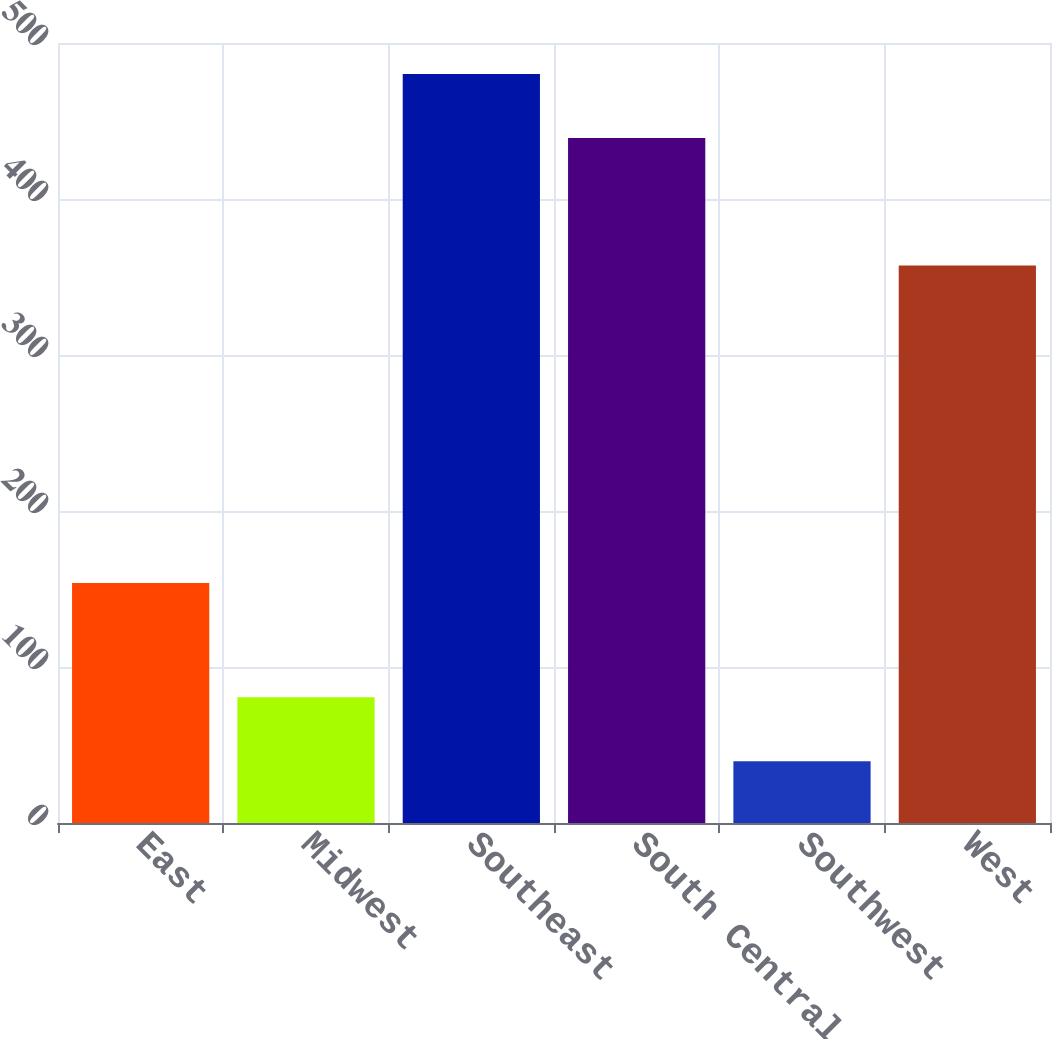Convert chart. <chart><loc_0><loc_0><loc_500><loc_500><bar_chart><fcel>East<fcel>Midwest<fcel>Southeast<fcel>South Central<fcel>Southwest<fcel>West<nl><fcel>153.9<fcel>80.67<fcel>480.17<fcel>439.1<fcel>39.6<fcel>357.3<nl></chart> 